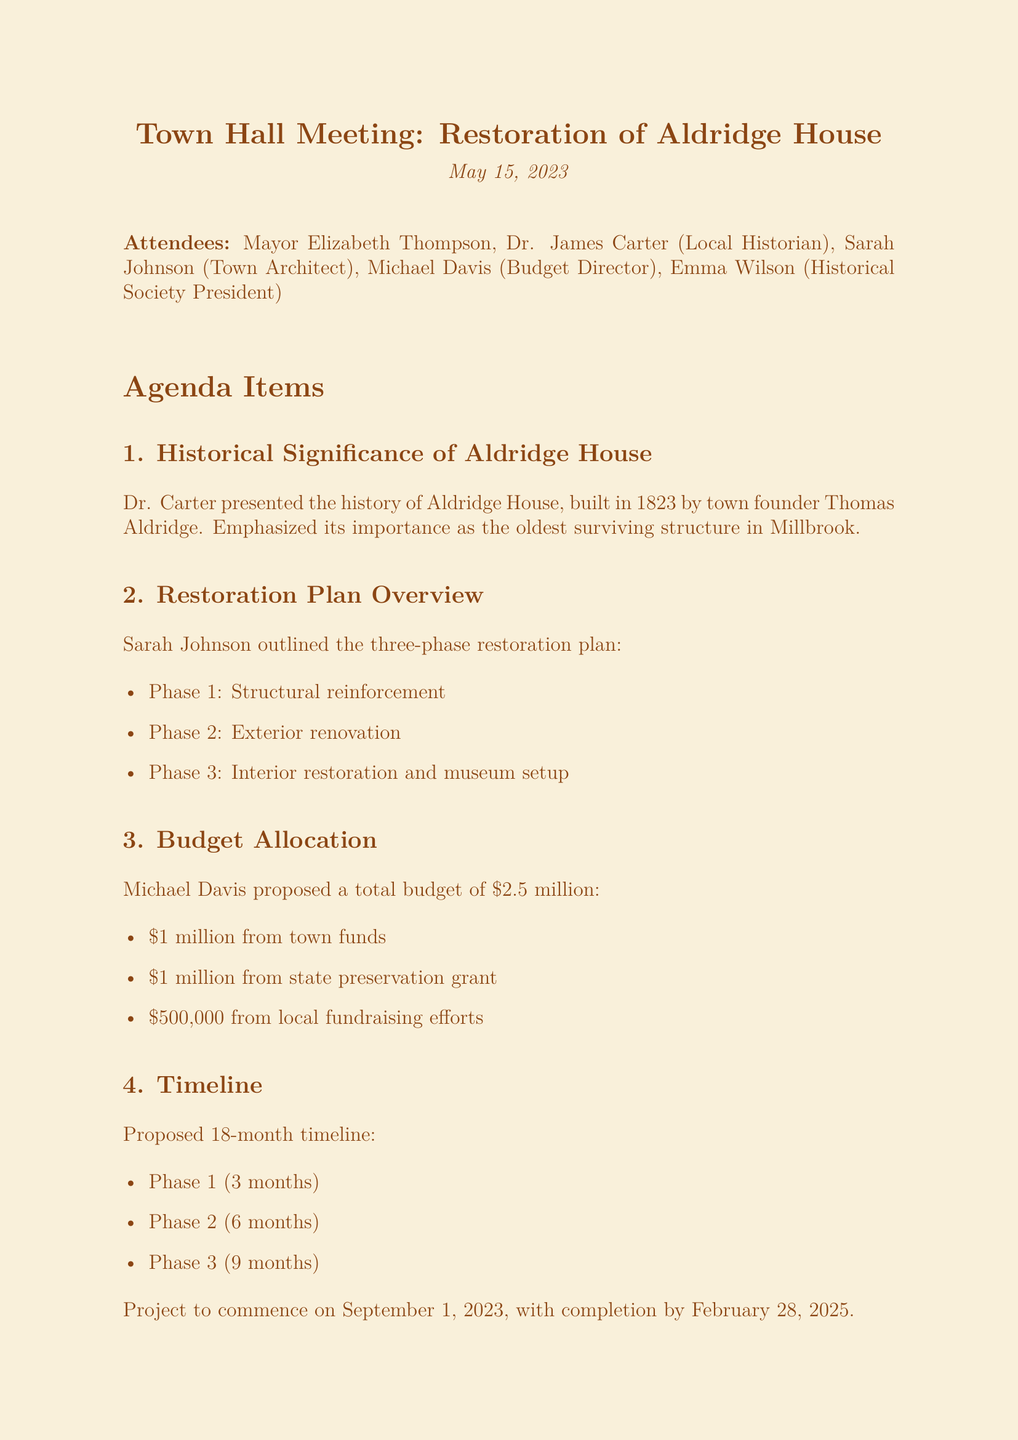What is the title of the meeting? The title of the meeting is found at the beginning of the document, and it is "Town Hall Meeting: Restoration of Aldridge House."
Answer: Town Hall Meeting: Restoration of Aldridge House Who presented the historical significance of Aldridge House? The document states that Dr. Carter presented the history of Aldridge House, reflecting his role in the discussion.
Answer: Dr. Carter What is the proposed budget for the restoration project? The budget allocation section reveals that the proposed total budget is $2.5 million.
Answer: $2.5 million What is the duration of Phase 1 of the restoration? Based on the timeline details, Phase 1 is set to last for 3 months.
Answer: 3 months When is the project scheduled to commence? The timeline section specifies that the project is proposed to commence on September 1, 2023.
Answer: September 1, 2023 What is one method suggested for community involvement in fundraising? Emma Wilson's suggestions include organizing a 'sponsor-a-brick' program to engage the community.
Answer: sponsor-a-brick program Which attendee is responsible for preparing the itemized budget breakdown? The action items list highlights Michael Davis as the person tasked with preparing the itemized budget breakdown.
Answer: Michael Davis What is the final deadline for the grant application? The next steps section indicates that the grant application needs to be finalized by June 1, 2023.
Answer: June 1, 2023 How many phases are outlined in the restoration plan? The document outlines a three-phase restoration plan as stated in the restoration plan overview.
Answer: three phases 